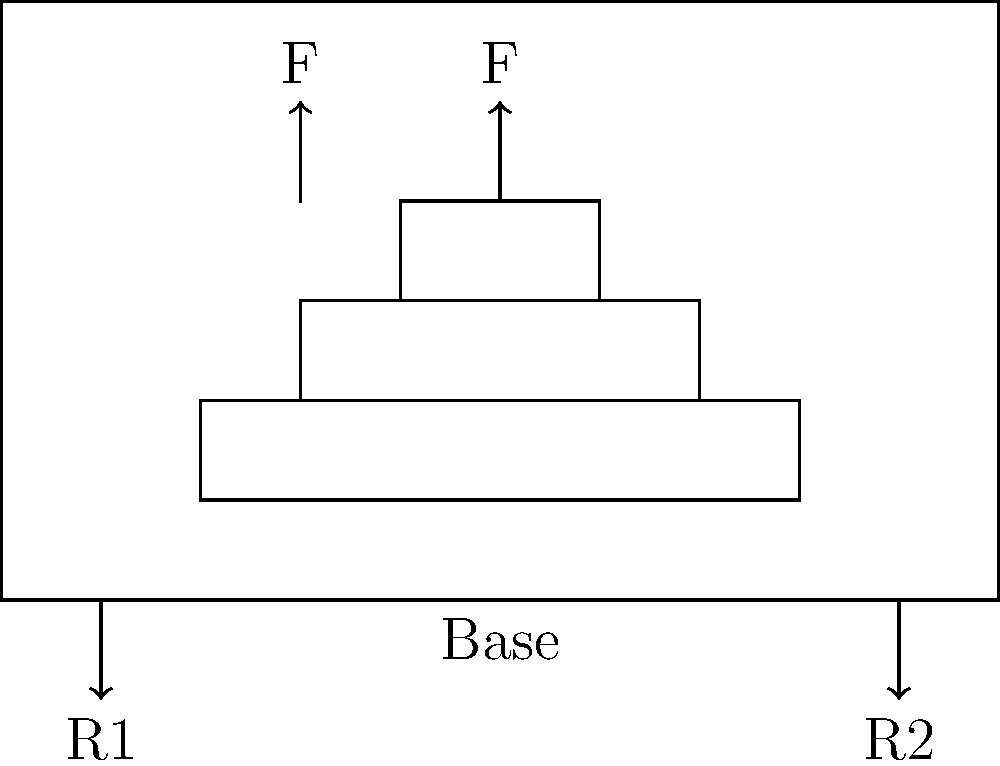In a beauty pageant, a tiered stage platform is designed as shown in the diagram. Two equal forces F are applied at the top tier. If the total weight of the contestants and the platform is negligible compared to the applied forces, what is the reaction force R2 at the right support in terms of F? Let's approach this step-by-step:

1. Observe that we have a symmetrical loading situation with two equal forces F applied at equal distances from the center of the platform.

2. Due to symmetry, we can conclude that the reaction forces at both supports will be equal. Let's call each reaction force R.

3. For equilibrium, the sum of all vertical forces must be zero:
   $$\sum F_y = 0$$
   $$R1 + R2 - 2F = 0$$
   $$2R - 2F = 0$$ (since R1 = R2 = R)

4. Solving for R:
   $$2R = 2F$$
   $$R = F$$

5. Therefore, each reaction force is equal to F.

6. The question specifically asks for R2, which is the reaction force at the right support.
Answer: R2 = F 